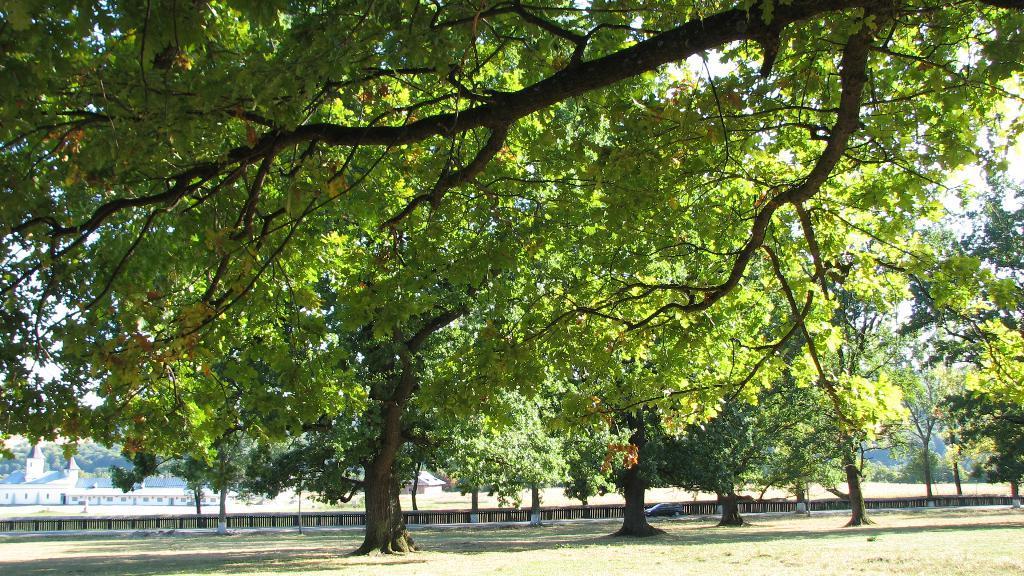Can you describe this image briefly? In this picture we can see grass, trees and car on the road. In the background of the image we can see houses, trees and sky. 